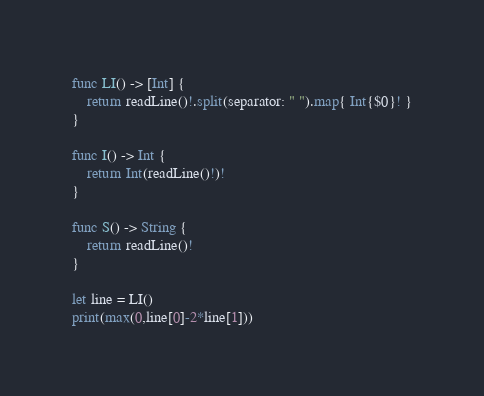<code> <loc_0><loc_0><loc_500><loc_500><_Swift_>func LI() -> [Int] {
    return readLine()!.split(separator: " ").map{ Int{$0}! }
}

func I() -> Int {
    return Int(readLine()!)!
}

func S() -> String {
    return readLine()!
}

let line = LI()
print(max(0,line[0]-2*line[1]))</code> 